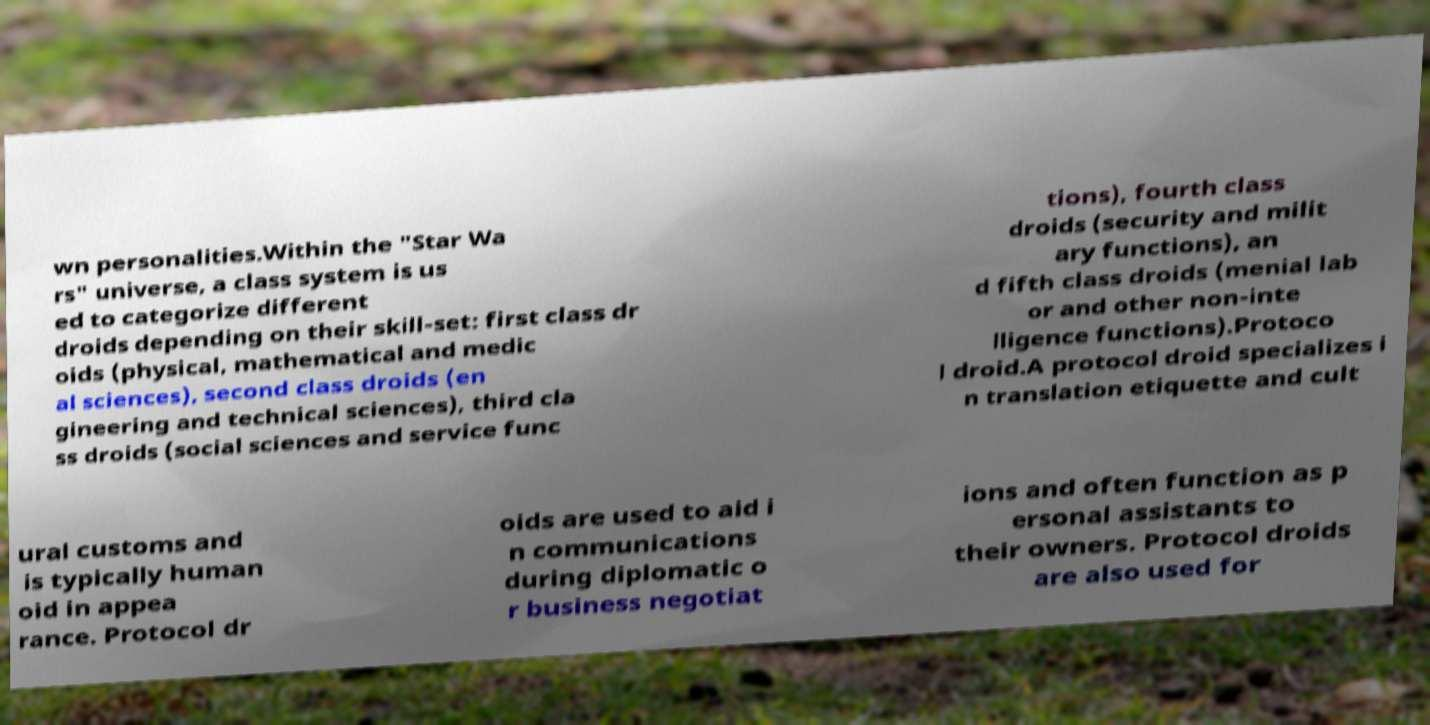What messages or text are displayed in this image? I need them in a readable, typed format. wn personalities.Within the "Star Wa rs" universe, a class system is us ed to categorize different droids depending on their skill-set: first class dr oids (physical, mathematical and medic al sciences), second class droids (en gineering and technical sciences), third cla ss droids (social sciences and service func tions), fourth class droids (security and milit ary functions), an d fifth class droids (menial lab or and other non-inte lligence functions).Protoco l droid.A protocol droid specializes i n translation etiquette and cult ural customs and is typically human oid in appea rance. Protocol dr oids are used to aid i n communications during diplomatic o r business negotiat ions and often function as p ersonal assistants to their owners. Protocol droids are also used for 